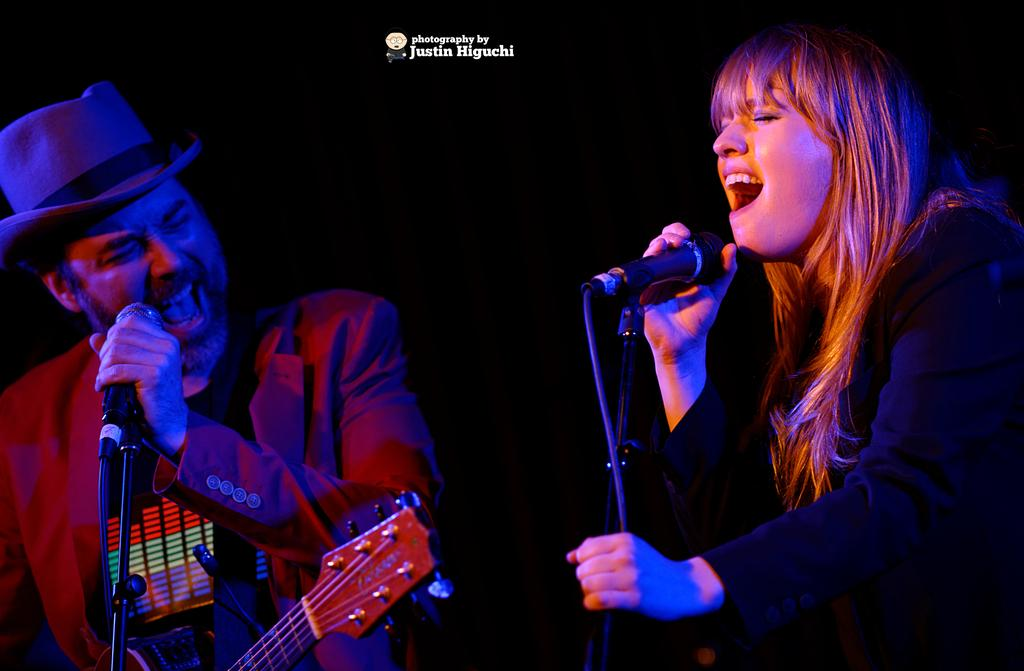What is the lighting condition in the image? The background of the image is dark. How many people are in the image? There is a woman and a man in the image. What are the woman and the man doing in the image? They are standing in front of a microphone and singing. What musical instrument can be seen in the image? There is a guitar present in the image. How many deer are visible in the image? There are no deer present in the image. What type of vessel is being used by the woman in the image? There is no vessel being used by the woman in the image. 